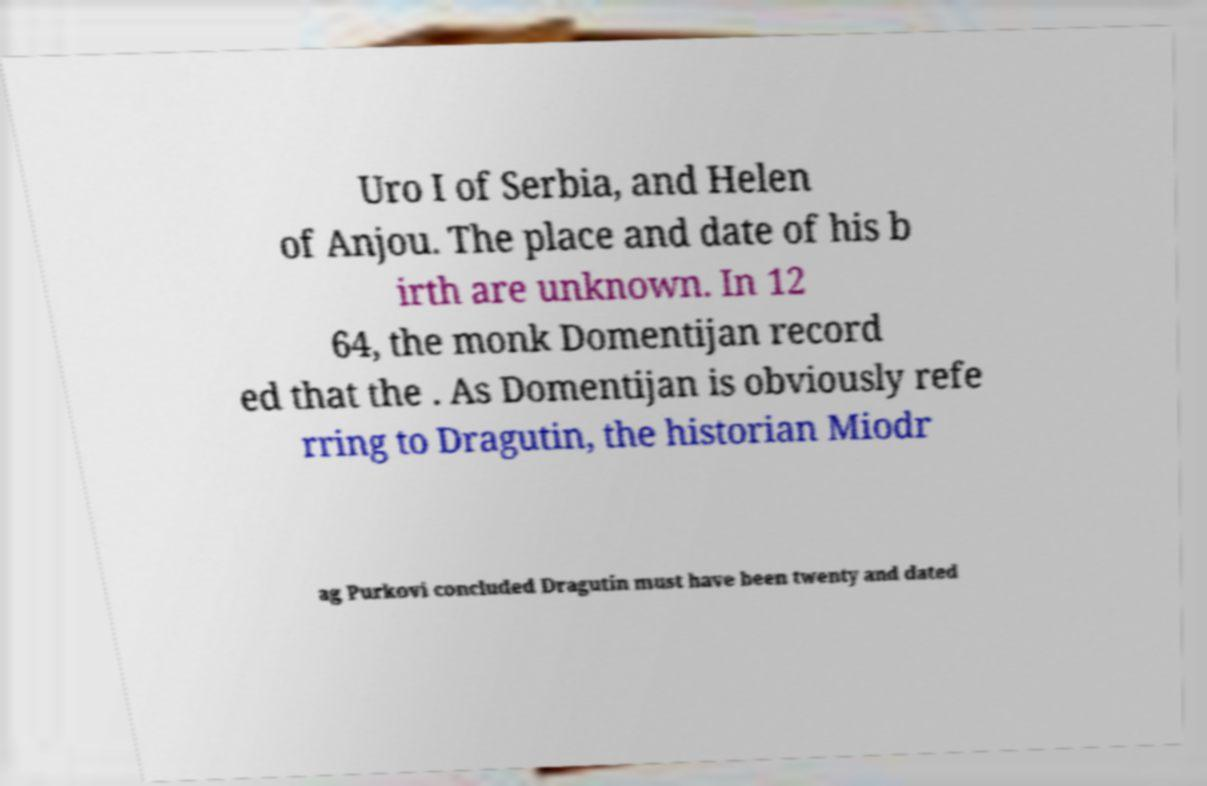Can you read and provide the text displayed in the image?This photo seems to have some interesting text. Can you extract and type it out for me? Uro I of Serbia, and Helen of Anjou. The place and date of his b irth are unknown. In 12 64, the monk Domentijan record ed that the . As Domentijan is obviously refe rring to Dragutin, the historian Miodr ag Purkovi concluded Dragutin must have been twenty and dated 